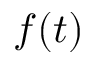<formula> <loc_0><loc_0><loc_500><loc_500>f ( t )</formula> 